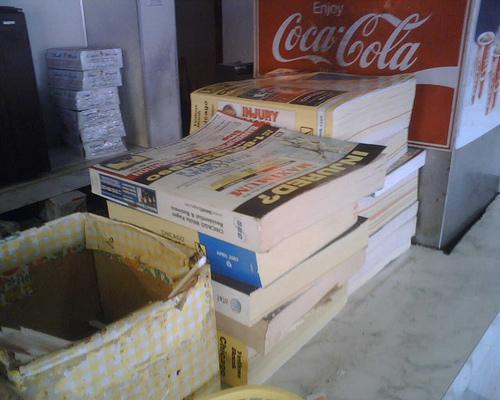How many stacks of phone books are visible?
Give a very brief answer. 2. How many books can be seen?
Give a very brief answer. 6. How many people have brown hair?
Give a very brief answer. 0. 